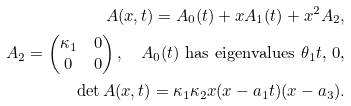Convert formula to latex. <formula><loc_0><loc_0><loc_500><loc_500>A ( x , t ) = A _ { 0 } ( t ) + x A _ { 1 } ( t ) + x ^ { 2 } A _ { 2 } , \\ A _ { 2 } = \begin{pmatrix} \kappa _ { 1 } & 0 \\ 0 & 0 \end{pmatrix} , \quad \text {$A_{0}(t)$ has eigenvalues $\theta_{1} t$, $0$,} \\ \det A ( x , t ) = \kappa _ { 1 } \kappa _ { 2 } x ( x - a _ { 1 } t ) ( x - a _ { 3 } ) .</formula> 